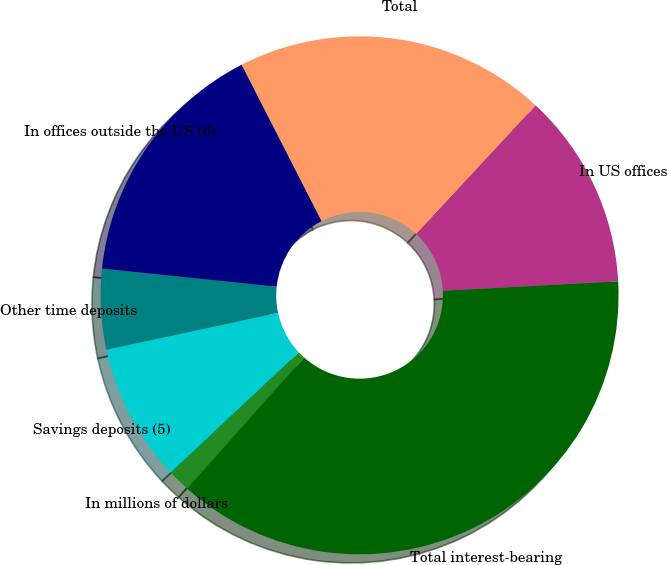Convert chart to OTSL. <chart><loc_0><loc_0><loc_500><loc_500><pie_chart><fcel>In millions of dollars<fcel>Savings deposits (5)<fcel>Other time deposits<fcel>In offices outside the US (6)<fcel>Total<fcel>In US offices<fcel>Total interest-bearing<nl><fcel>1.42%<fcel>8.62%<fcel>5.02%<fcel>15.83%<fcel>19.43%<fcel>12.23%<fcel>37.44%<nl></chart> 